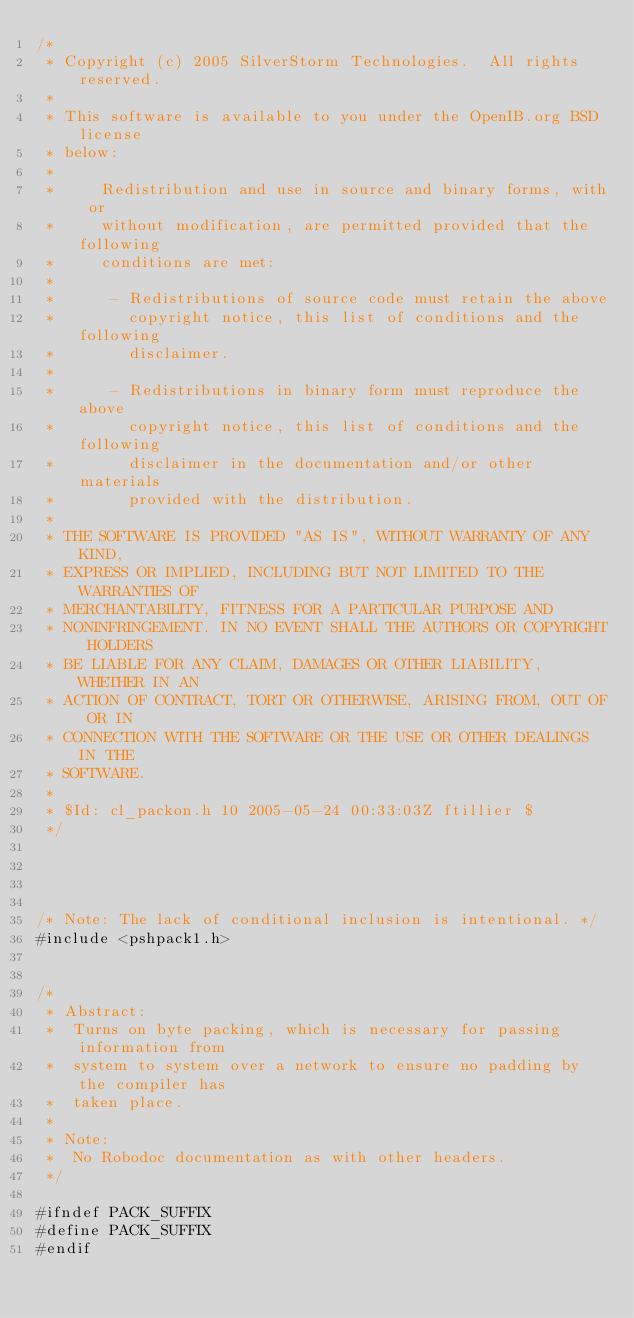<code> <loc_0><loc_0><loc_500><loc_500><_C_>/*
 * Copyright (c) 2005 SilverStorm Technologies.  All rights reserved.
 *
 * This software is available to you under the OpenIB.org BSD license
 * below:
 *
 *     Redistribution and use in source and binary forms, with or
 *     without modification, are permitted provided that the following
 *     conditions are met:
 *
 *      - Redistributions of source code must retain the above
 *        copyright notice, this list of conditions and the following
 *        disclaimer.
 *
 *      - Redistributions in binary form must reproduce the above
 *        copyright notice, this list of conditions and the following
 *        disclaimer in the documentation and/or other materials
 *        provided with the distribution.
 *
 * THE SOFTWARE IS PROVIDED "AS IS", WITHOUT WARRANTY OF ANY KIND,
 * EXPRESS OR IMPLIED, INCLUDING BUT NOT LIMITED TO THE WARRANTIES OF
 * MERCHANTABILITY, FITNESS FOR A PARTICULAR PURPOSE AND
 * NONINFRINGEMENT. IN NO EVENT SHALL THE AUTHORS OR COPYRIGHT HOLDERS
 * BE LIABLE FOR ANY CLAIM, DAMAGES OR OTHER LIABILITY, WHETHER IN AN
 * ACTION OF CONTRACT, TORT OR OTHERWISE, ARISING FROM, OUT OF OR IN
 * CONNECTION WITH THE SOFTWARE OR THE USE OR OTHER DEALINGS IN THE
 * SOFTWARE.
 *
 * $Id: cl_packon.h 10 2005-05-24 00:33:03Z ftillier $
 */




/* Note: The lack of conditional inclusion is intentional. */
#include <pshpack1.h>


/*
 * Abstract:
 *  Turns on byte packing, which is necessary for passing information from
 *	system to system over a network to ensure no padding by the compiler has 
 *	taken place.
 *
 * Note:
 *	No Robodoc documentation as with other headers.
 */

#ifndef PACK_SUFFIX
#define PACK_SUFFIX
#endif 
</code> 